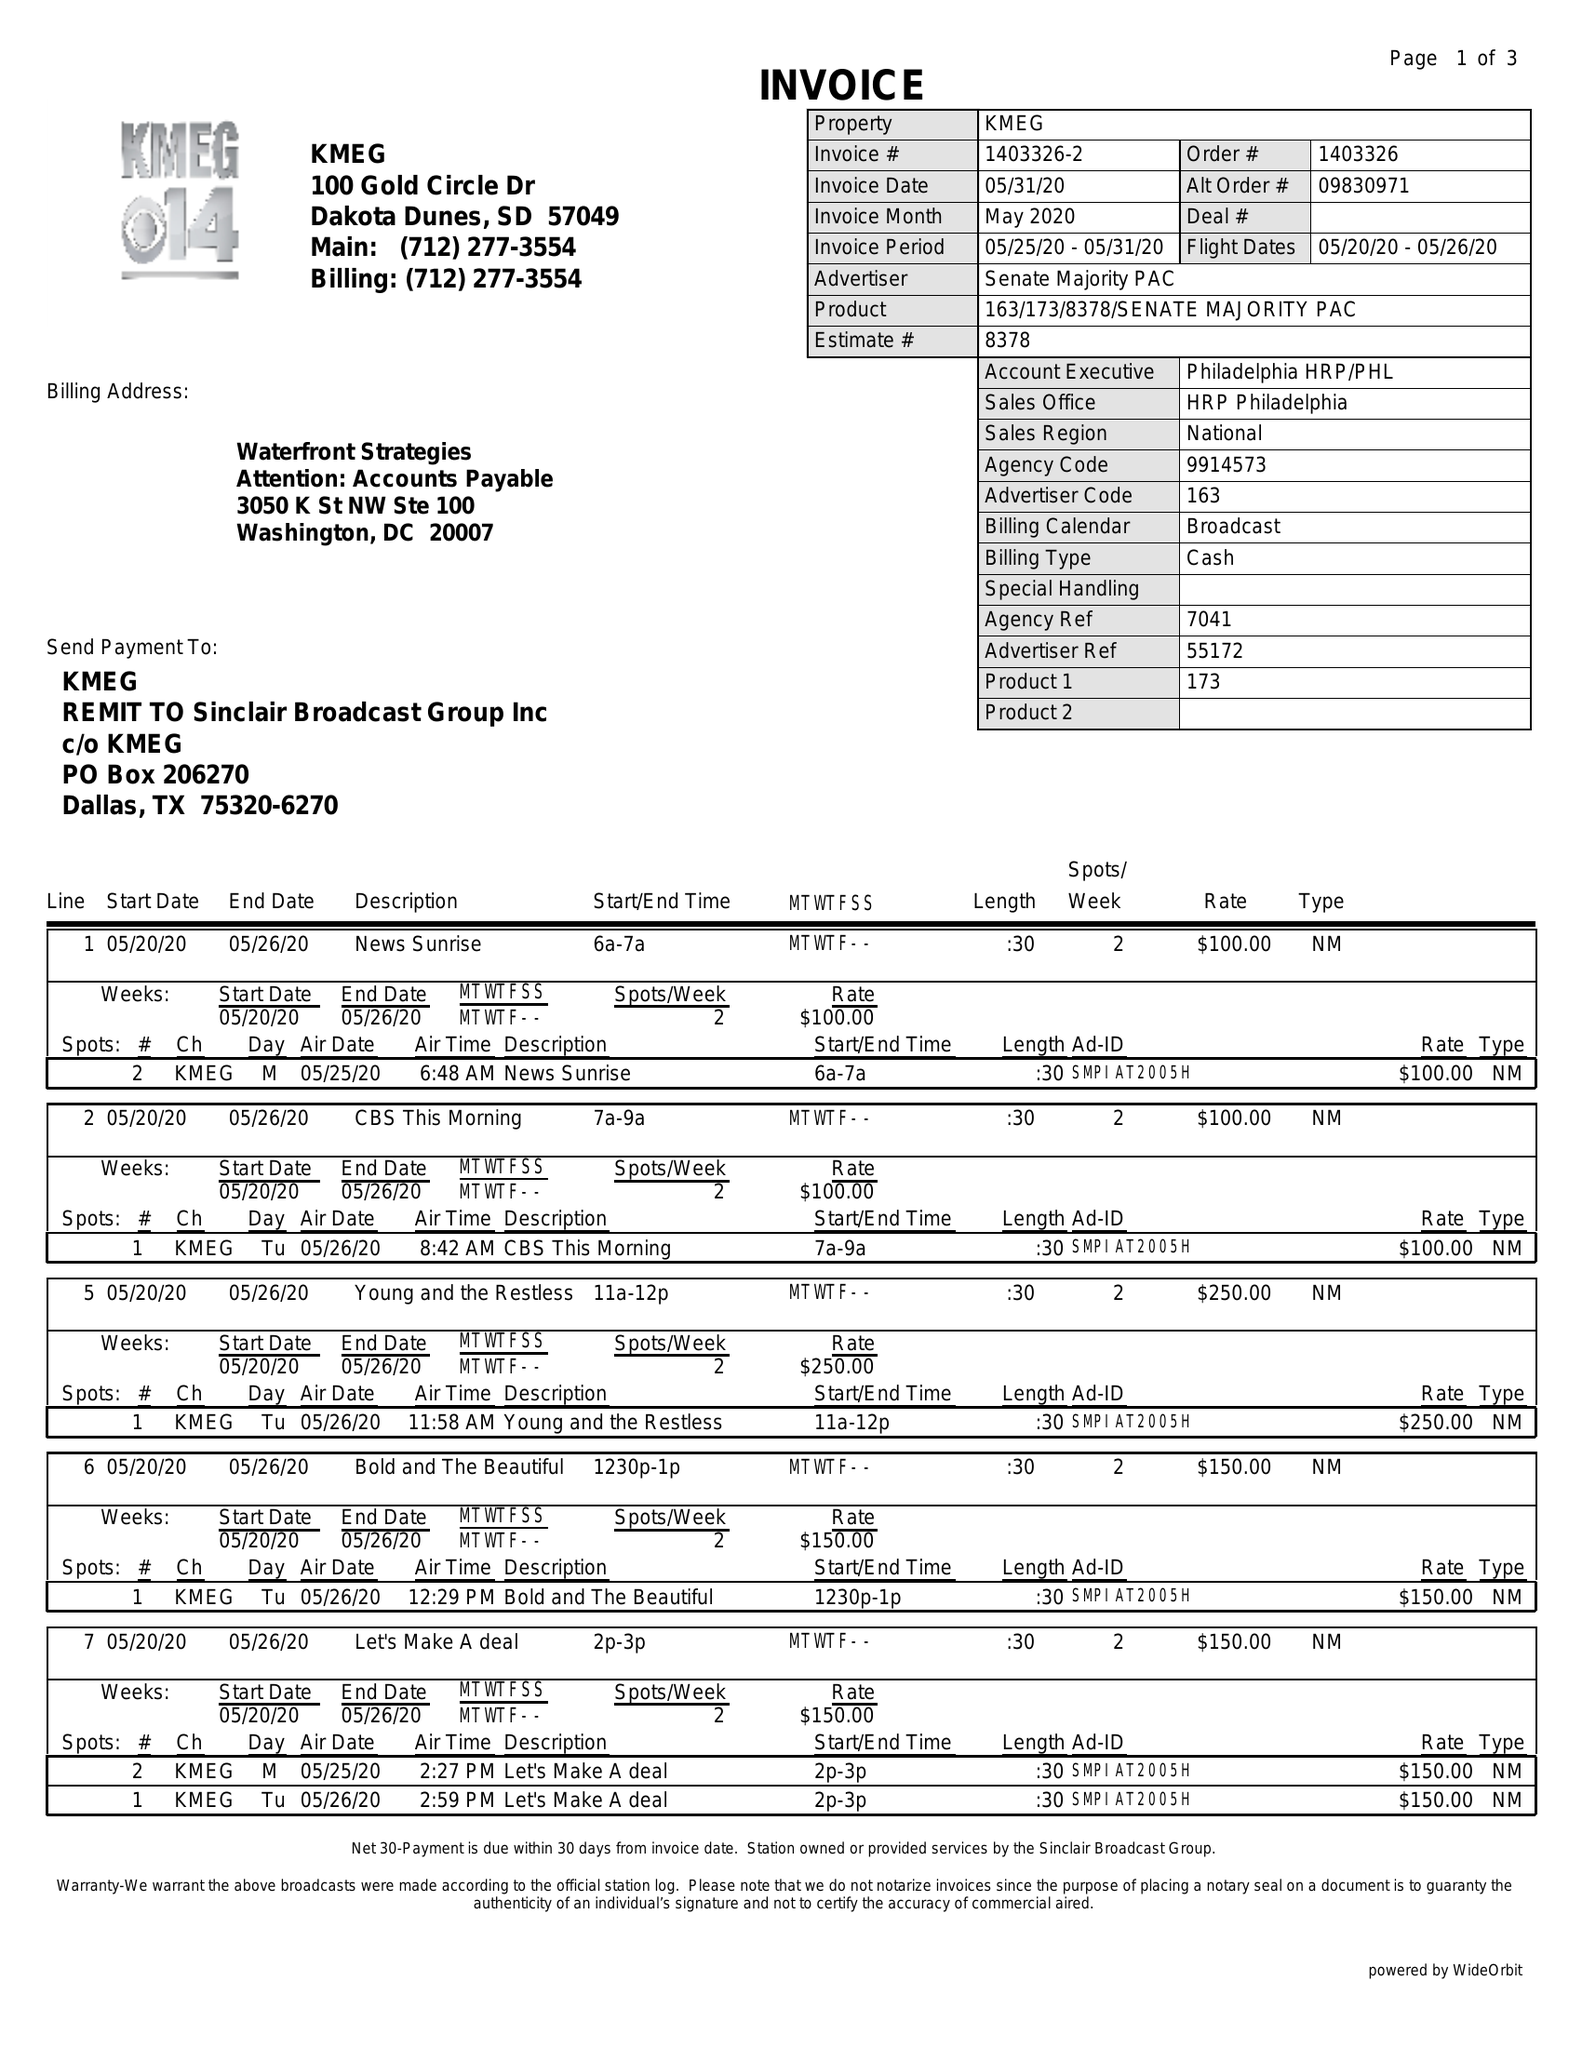What is the value for the flight_to?
Answer the question using a single word or phrase. 05/26/20 